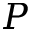<formula> <loc_0><loc_0><loc_500><loc_500>P</formula> 